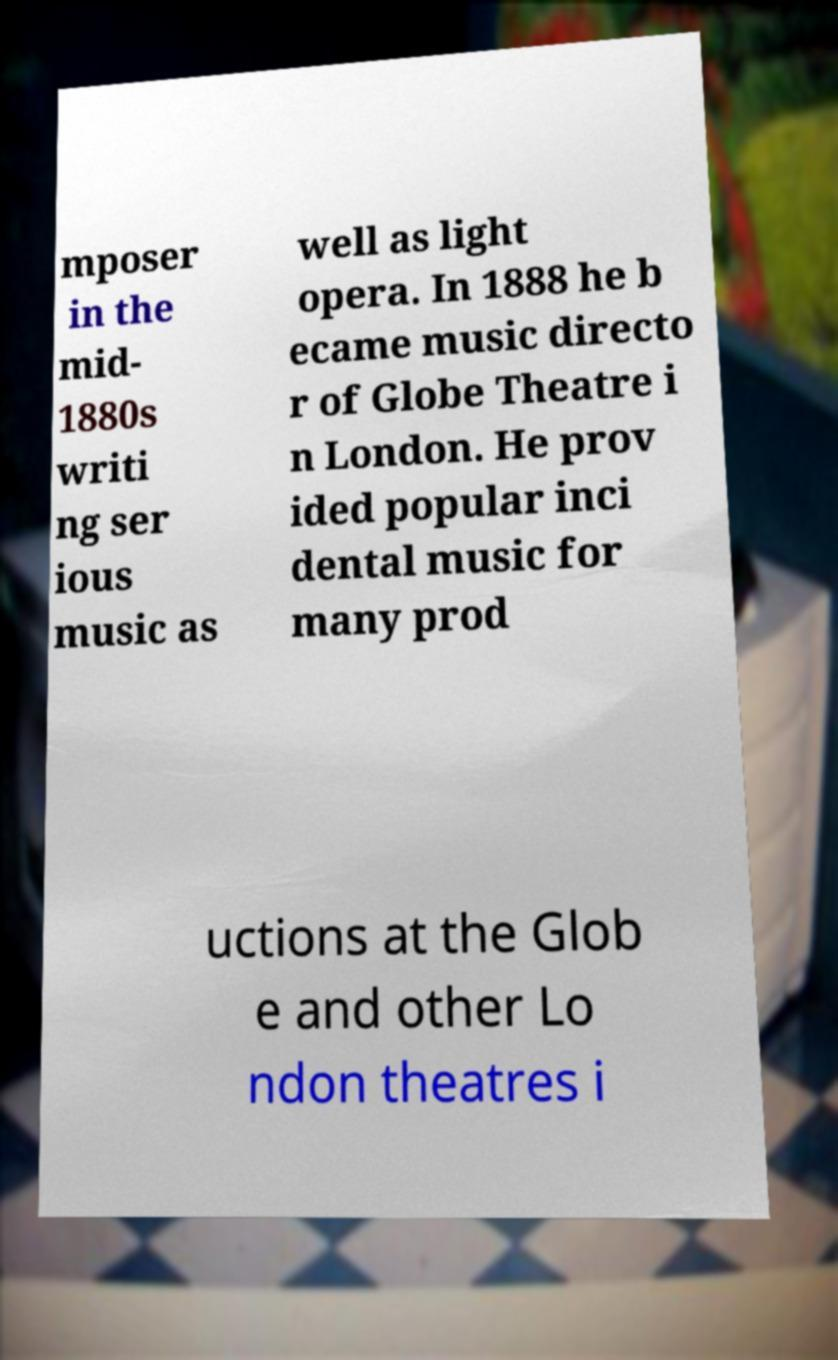Could you assist in decoding the text presented in this image and type it out clearly? mposer in the mid- 1880s writi ng ser ious music as well as light opera. In 1888 he b ecame music directo r of Globe Theatre i n London. He prov ided popular inci dental music for many prod uctions at the Glob e and other Lo ndon theatres i 